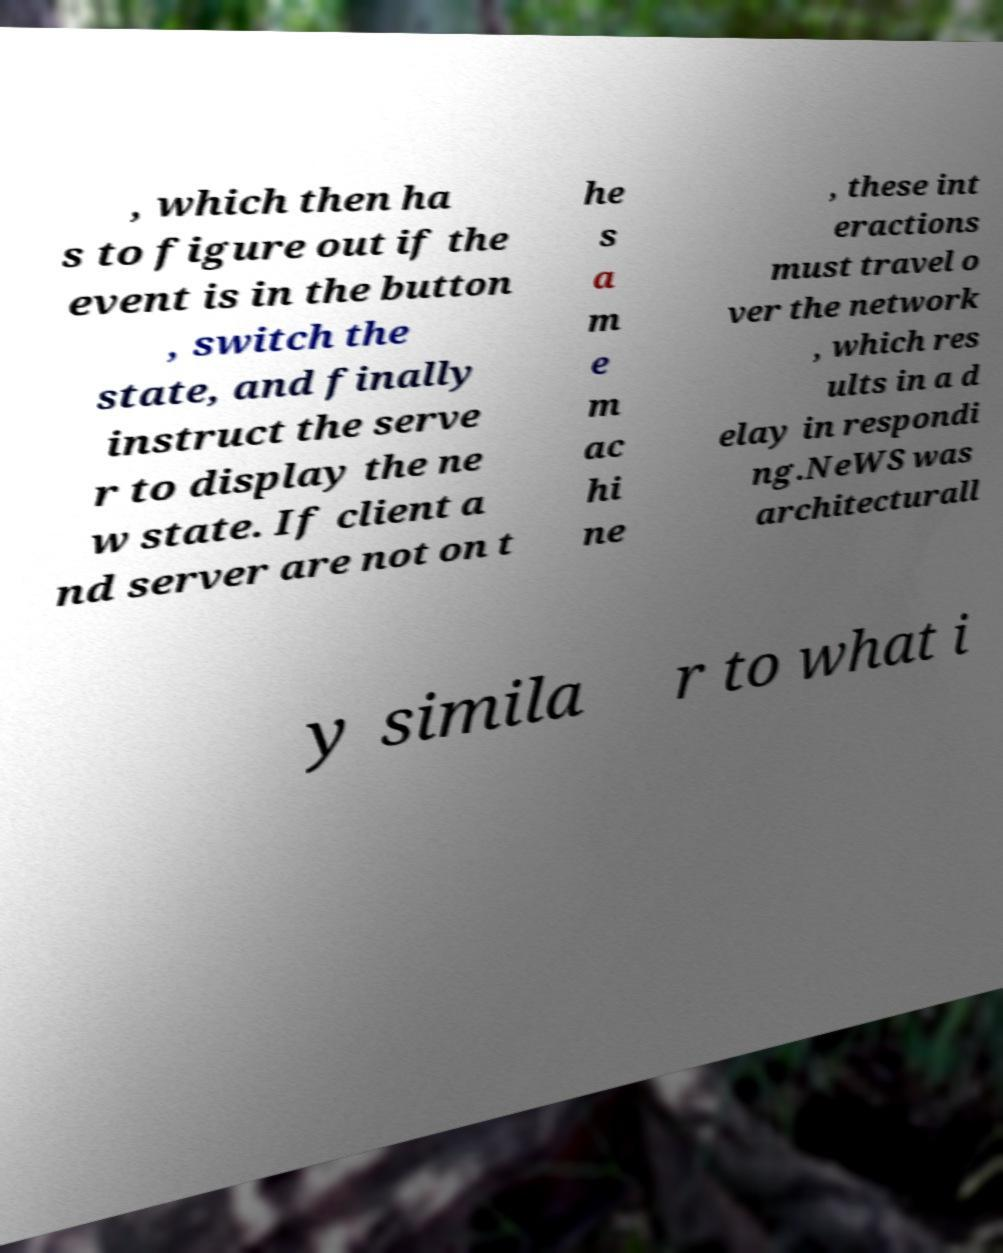Could you extract and type out the text from this image? , which then ha s to figure out if the event is in the button , switch the state, and finally instruct the serve r to display the ne w state. If client a nd server are not on t he s a m e m ac hi ne , these int eractions must travel o ver the network , which res ults in a d elay in respondi ng.NeWS was architecturall y simila r to what i 